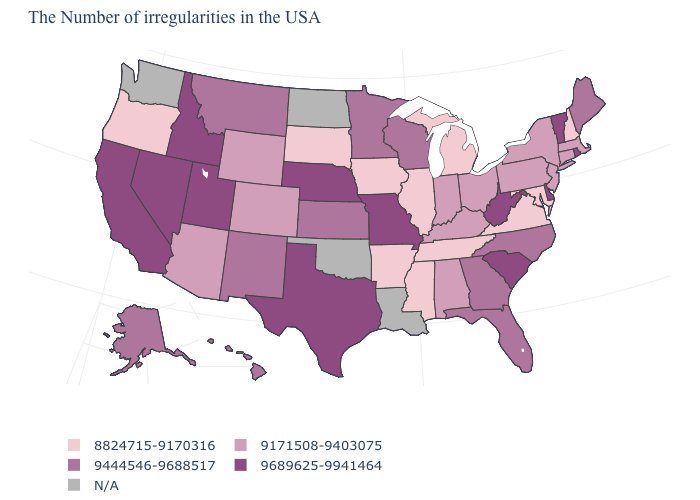Which states have the lowest value in the West?
Concise answer only. Oregon. Name the states that have a value in the range 9171508-9403075?
Be succinct. Massachusetts, Connecticut, New York, New Jersey, Pennsylvania, Ohio, Kentucky, Indiana, Alabama, Wyoming, Colorado, Arizona. What is the value of Maine?
Keep it brief. 9444546-9688517. What is the highest value in states that border Pennsylvania?
Quick response, please. 9689625-9941464. Name the states that have a value in the range 9171508-9403075?
Answer briefly. Massachusetts, Connecticut, New York, New Jersey, Pennsylvania, Ohio, Kentucky, Indiana, Alabama, Wyoming, Colorado, Arizona. What is the value of Kansas?
Answer briefly. 9444546-9688517. What is the highest value in the USA?
Answer briefly. 9689625-9941464. Does Vermont have the lowest value in the USA?
Quick response, please. No. What is the lowest value in the USA?
Short answer required. 8824715-9170316. What is the value of Ohio?
Answer briefly. 9171508-9403075. What is the lowest value in the South?
Give a very brief answer. 8824715-9170316. Which states hav the highest value in the South?
Write a very short answer. Delaware, South Carolina, West Virginia, Texas. Does the first symbol in the legend represent the smallest category?
Write a very short answer. Yes. What is the value of New Jersey?
Be succinct. 9171508-9403075. 